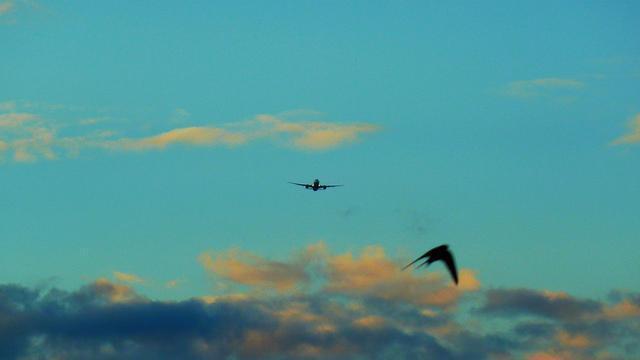How many birds?
Give a very brief answer. 1. How many planes?
Give a very brief answer. 1. How many people have theri arm outstreched in front of them?
Give a very brief answer. 0. 